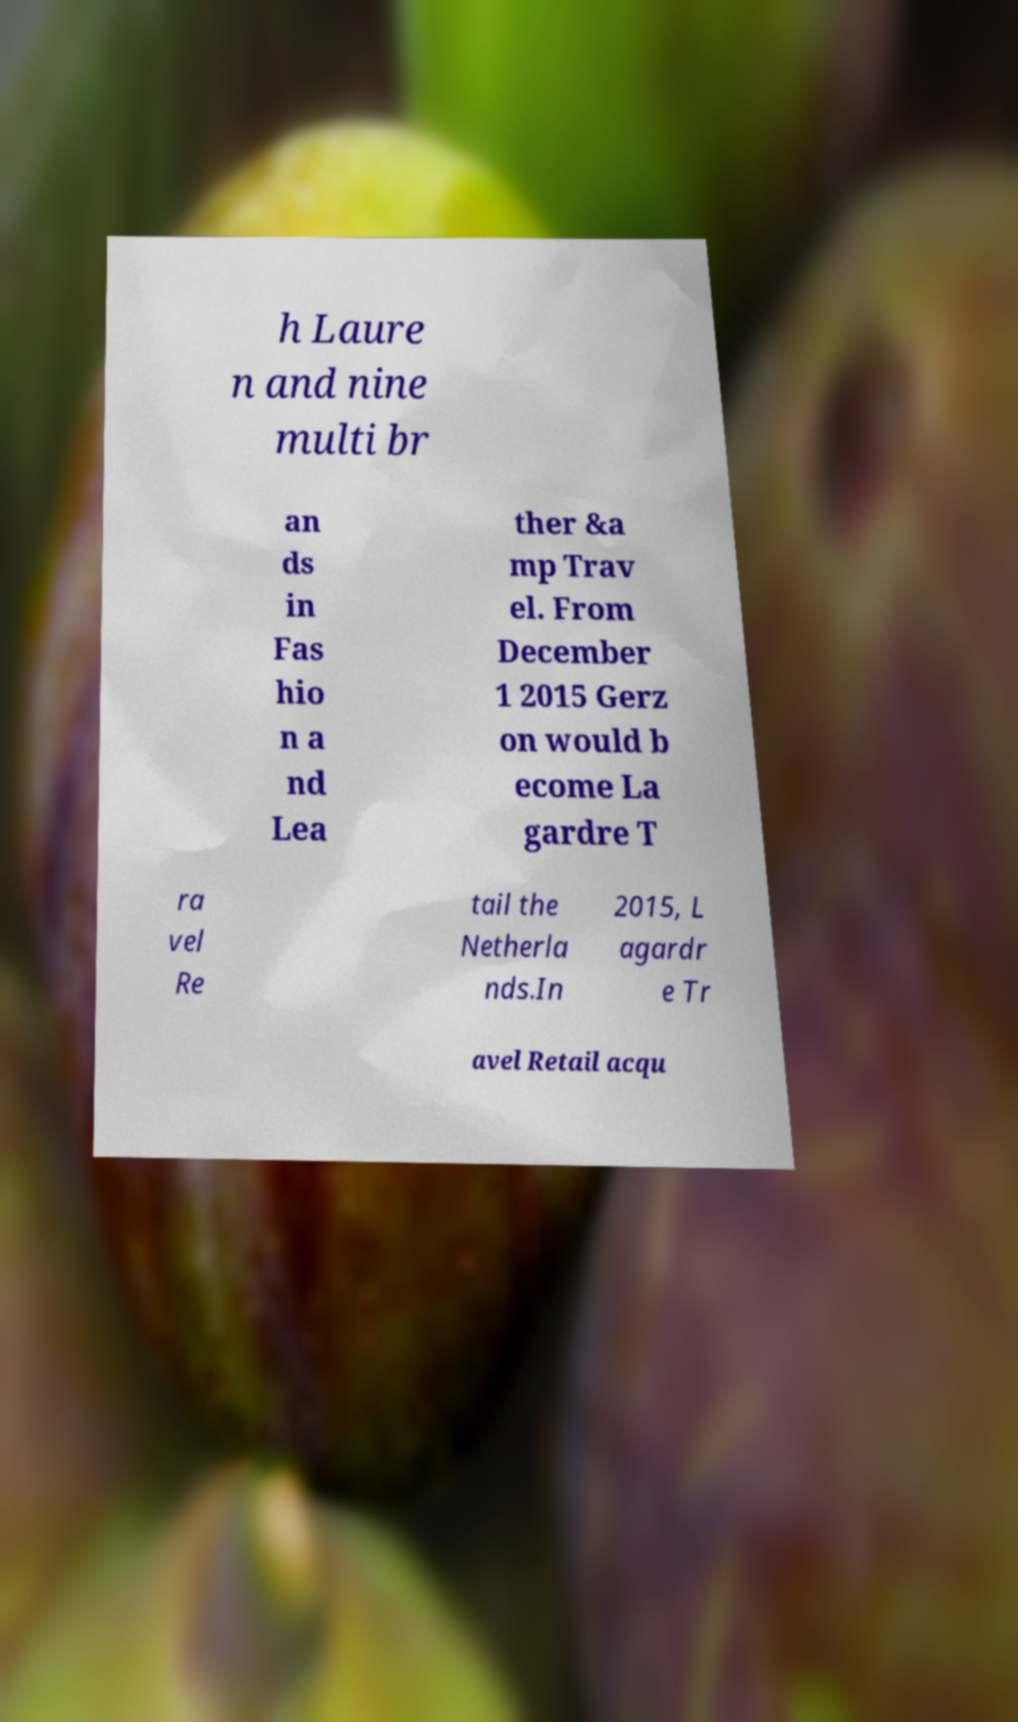Could you assist in decoding the text presented in this image and type it out clearly? h Laure n and nine multi br an ds in Fas hio n a nd Lea ther &a mp Trav el. From December 1 2015 Gerz on would b ecome La gardre T ra vel Re tail the Netherla nds.In 2015, L agardr e Tr avel Retail acqu 